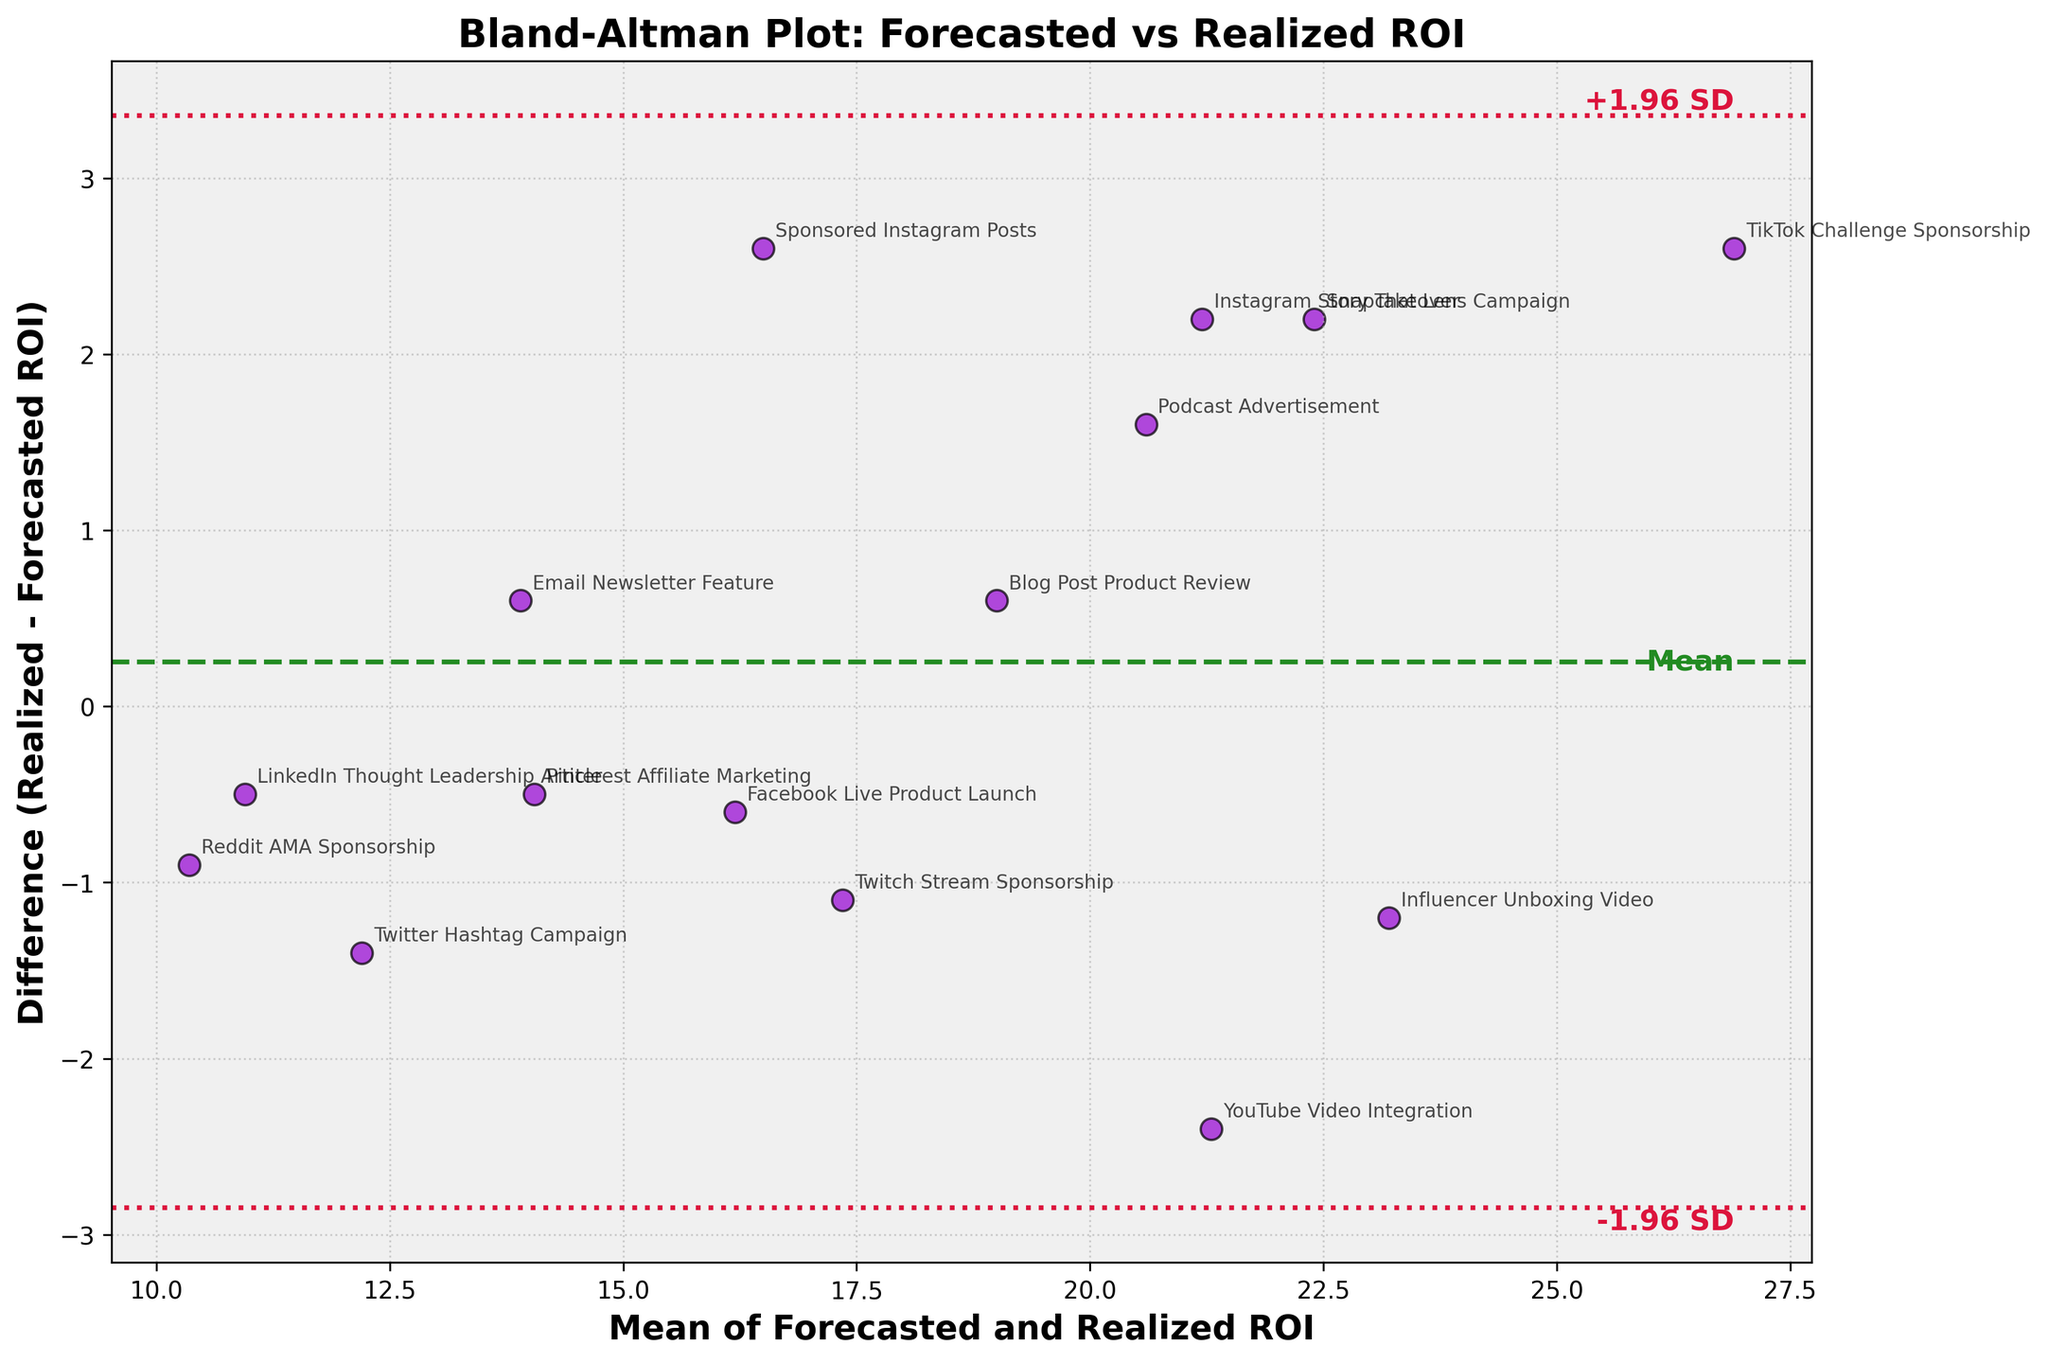What is the title of the plot? The title is usually displayed at the top of the plot, in this case, it reads "Bland-Altman Plot: Forecasted vs Realized ROI".
Answer: Bland-Altman Plot: Forecasted vs Realized ROI How many data points are plotted in the figure? Each data point represents a 'Strategy', and we have 15 unique 'Strategy' entries in the dataset that are plotted in the figure as points.
Answer: 15 What do the x and y axes represent in the plot? The x-axis represents the 'Mean of Forecasted and Realized ROI', while the y-axis represents the 'Difference (Realized - Forecasted ROI)', as labeled in the figure.
Answer: Mean of Forecasted and Realized ROI, Difference (Realized - Forecasted ROI) Which strategy has the highest realized ROI compared to its forecasted ROI? To find this, you look for the point with the highest positive y-coordinate (difference), which represents Realized ROI being higher than Forecasted ROI. The 'TikTok Challenge Sponsorship' strategy shows the highest difference (28.2 - 25.6 = 2.6).
Answer: TikTok Challenge Sponsorship What is the mean difference (md) line value? The mean difference (md) line is the horizontal line drawn at the average value of the differences between Realized and Forecasted ROI. This value can be seen on the figure text labeled as 'Mean'.
Answer: Mean Which strategy has a forecasted ROI closest to its realized ROI? The strategy with the point closest to the y=0 line has the smallest difference between forecasted and realized ROI. 'Pinterest Affiliate Marketing' has a difference of 0.5, the smallest in this plot.
Answer: Pinterest Affiliate Marketing What is the range of the mean values of Forecasted and Realized ROI across all strategies? By examining the x-axis, the lowest mean value (around 10.95) comes from 'Reddit AMA Sponsorship' and the highest mean value (around 26.9) is for 'TikTok Challenge Sponsorship'. Thus, the range is approximately 16.
Answer: 10.95 to 26.9 (approximately 16) Are there any strategies that have a negative difference between realized and forecasted ROI? Look at data points below the y=0 line, representing negative differences. 'YouTube Video Integration', 'Twitter Hashtag Campaign', 'Facebook Live Product Launch', among others have negative differences.
Answer: Yes What is the variability range for the differences between realized and forecasted ROI? The variability can be seen through the horizontal dotted lines representing ±1.96 standard deviations from the mean difference. This range shows the spread of data points around the mean difference value.
Answer: ±1.96 SD Are most of the points clustered around the mean difference line? Observing the distance of the majority of data points from the mean line (dark green dashed line), most points are relatively close, indicating that the forecasted ROIs are usually fairly accurate with some deviations.
Answer: Yes 